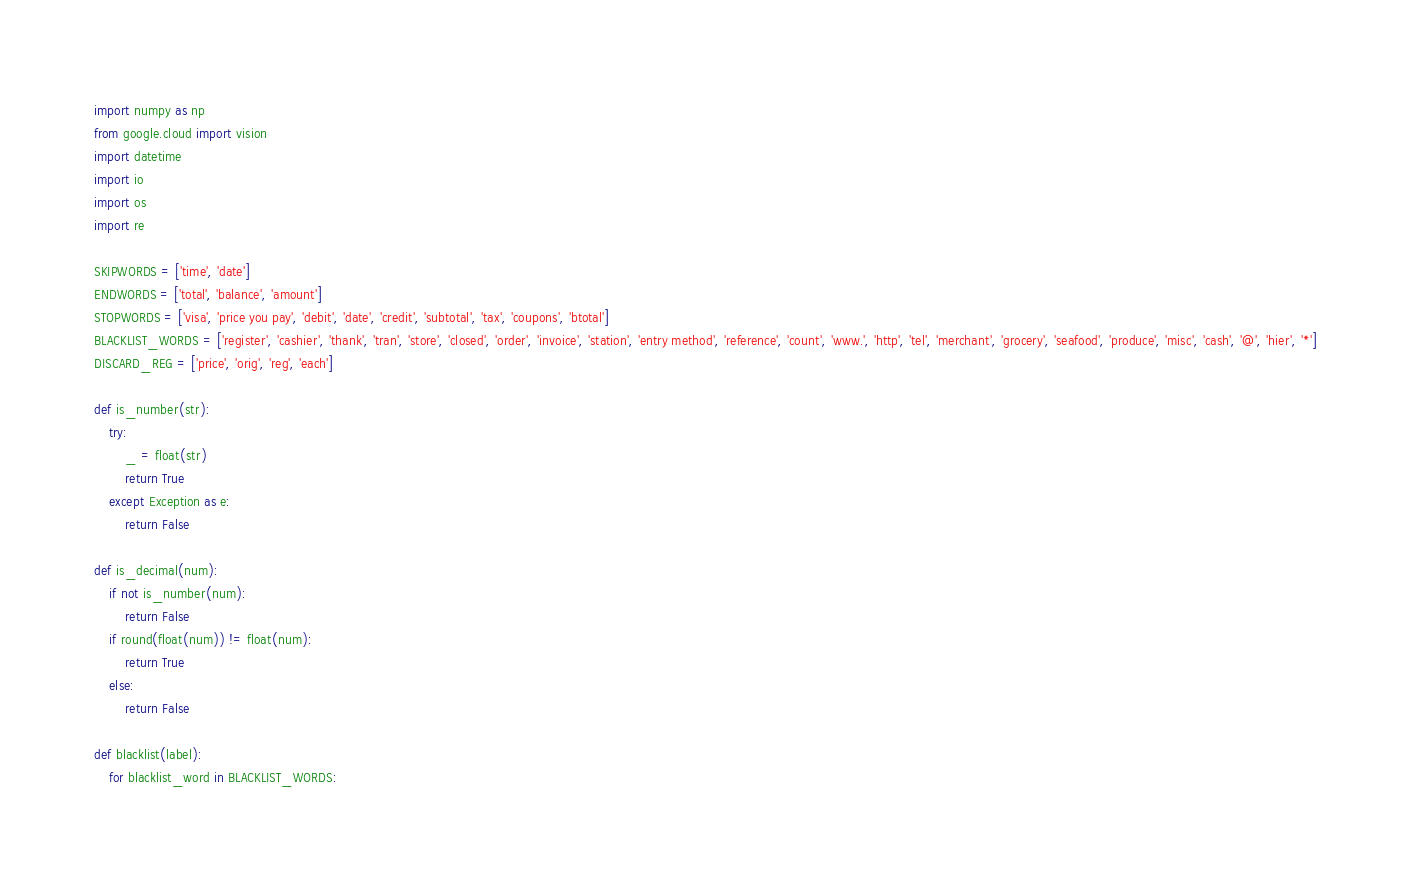Convert code to text. <code><loc_0><loc_0><loc_500><loc_500><_Python_>import numpy as np
from google.cloud import vision
import datetime
import io
import os
import re

SKIPWORDS = ['time', 'date']
ENDWORDS = ['total', 'balance', 'amount']
STOPWORDS = ['visa', 'price you pay', 'debit', 'date', 'credit', 'subtotal', 'tax', 'coupons', 'btotal']
BLACKLIST_WORDS = ['register', 'cashier', 'thank', 'tran', 'store', 'closed', 'order', 'invoice', 'station', 'entry method', 'reference', 'count', 'www.', 'http', 'tel', 'merchant', 'grocery', 'seafood', 'produce', 'misc', 'cash', '@', 'hier', '*']
DISCARD_REG = ['price', 'orig', 'reg', 'each']

def is_number(str): 
    try: 
        _ = float(str)
        return True
    except Exception as e: 
        return False

def is_decimal(num): 
    if not is_number(num): 
        return False
    if round(float(num)) != float(num):
        return True
    else: 
        return False

def blacklist(label): 
    for blacklist_word in BLACKLIST_WORDS: </code> 